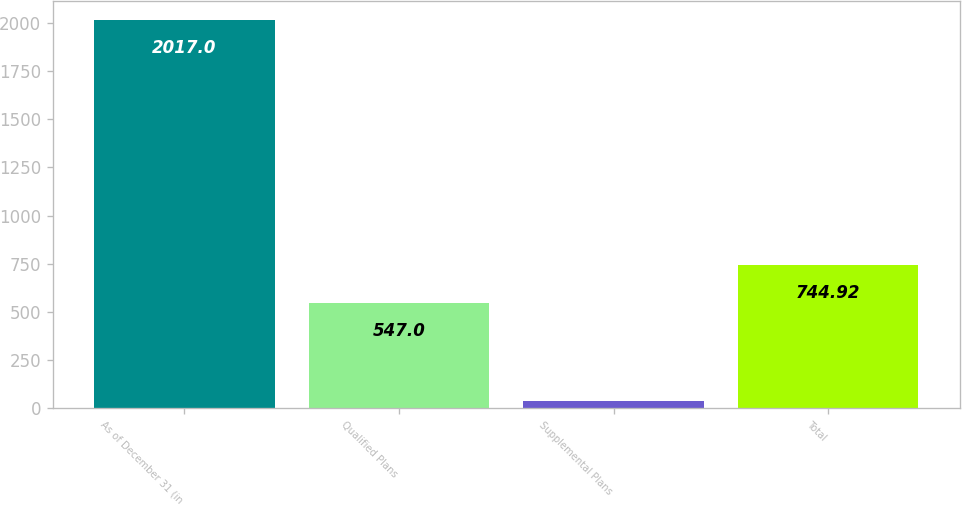<chart> <loc_0><loc_0><loc_500><loc_500><bar_chart><fcel>As of December 31 (in<fcel>Qualified Plans<fcel>Supplemental Plans<fcel>Total<nl><fcel>2017<fcel>547<fcel>37.8<fcel>744.92<nl></chart> 